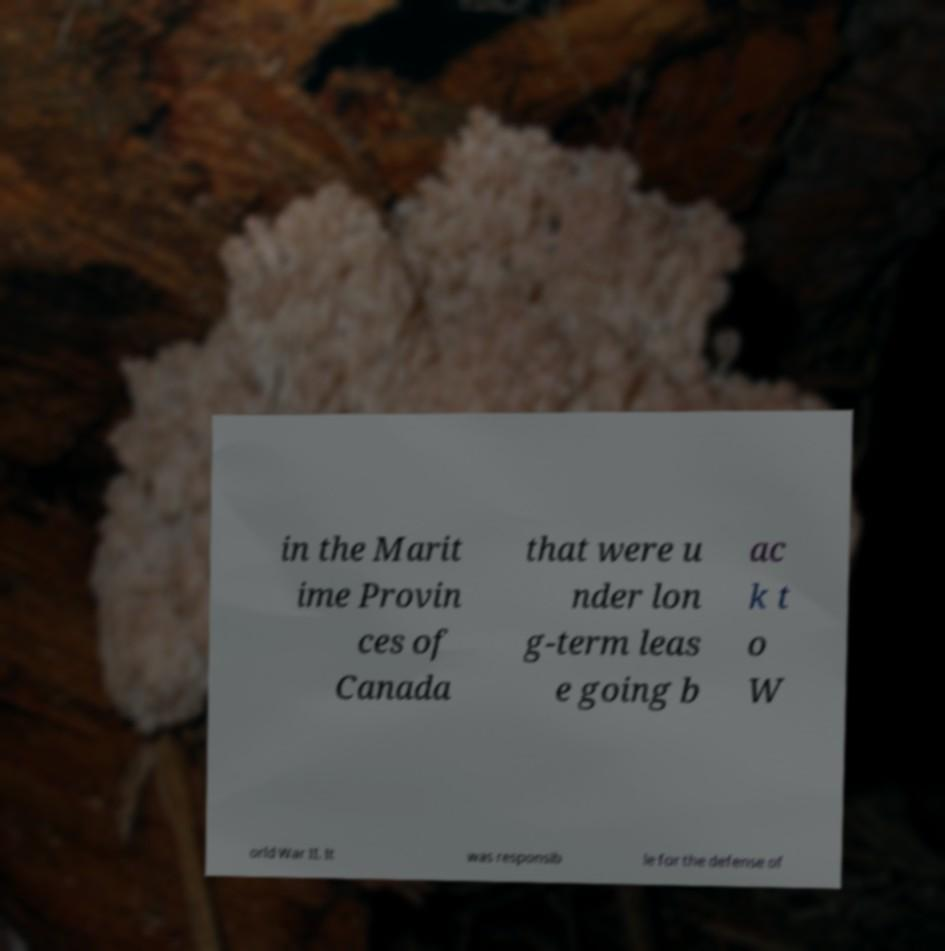Can you accurately transcribe the text from the provided image for me? in the Marit ime Provin ces of Canada that were u nder lon g-term leas e going b ac k t o W orld War II. It was responsib le for the defense of 